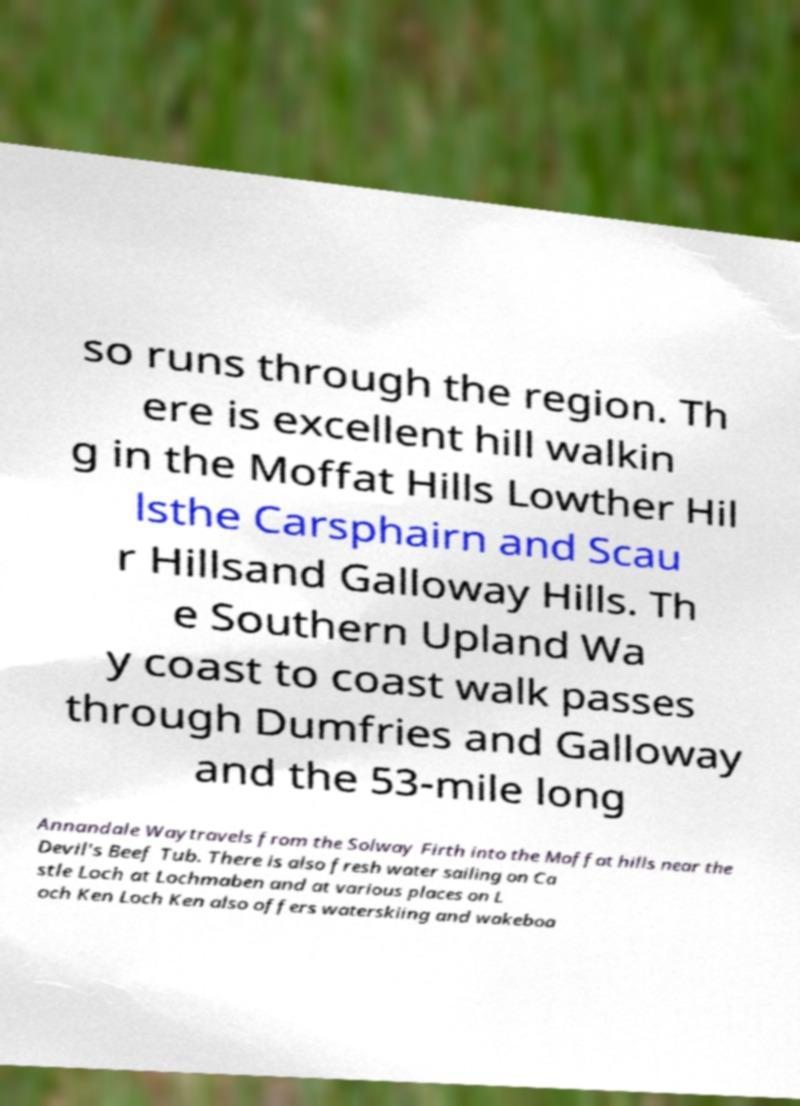Please read and relay the text visible in this image. What does it say? so runs through the region. Th ere is excellent hill walkin g in the Moffat Hills Lowther Hil lsthe Carsphairn and Scau r Hillsand Galloway Hills. Th e Southern Upland Wa y coast to coast walk passes through Dumfries and Galloway and the 53-mile long Annandale Waytravels from the Solway Firth into the Moffat hills near the Devil's Beef Tub. There is also fresh water sailing on Ca stle Loch at Lochmaben and at various places on L och Ken Loch Ken also offers waterskiing and wakeboa 